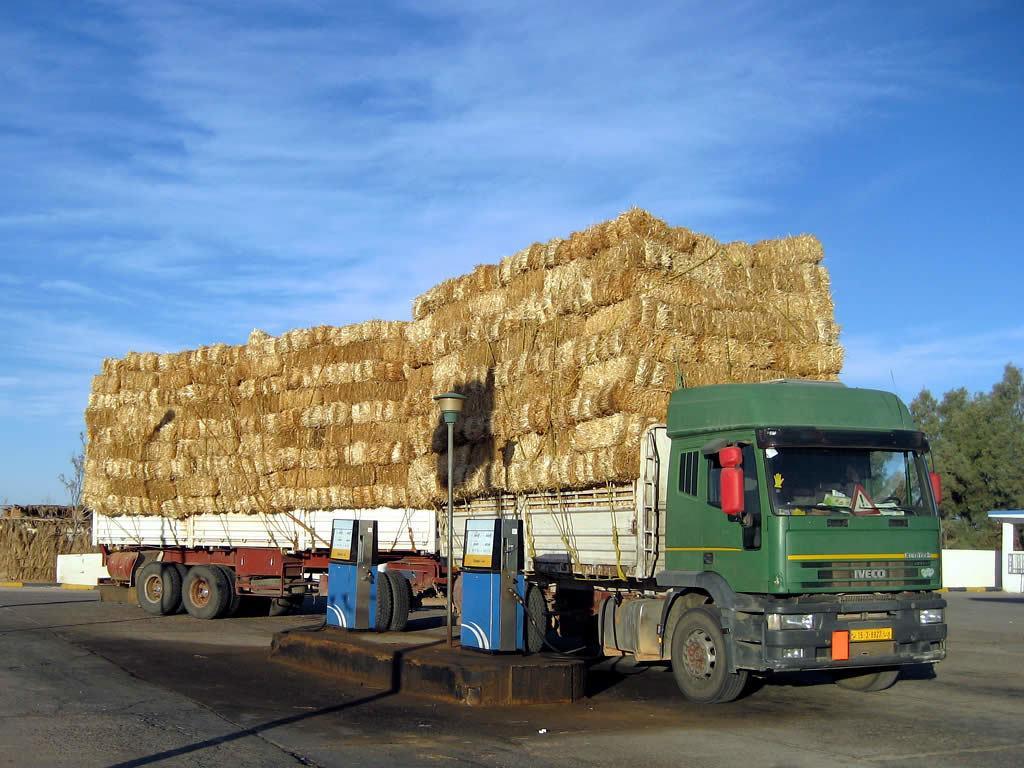Describe this image in one or two sentences. In this picture, we see a semi trailer truck containing the objects which look like the door mats. This truck is in white, brown and green color. Beside that, we see a petrol station air pump. On the right side, we see a white wall. There are trees in the background. At the bottom, we see the road and water. At the top, we see the sky, which is blue in color. 